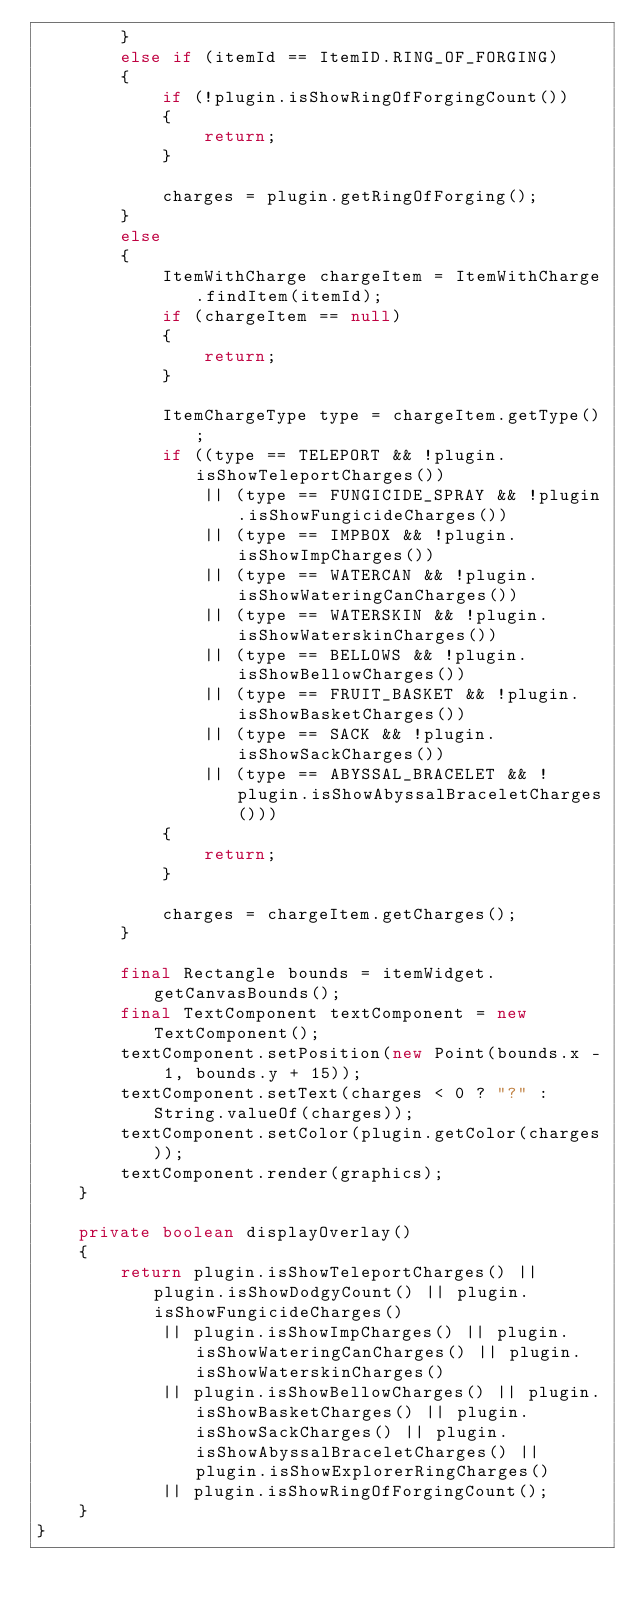Convert code to text. <code><loc_0><loc_0><loc_500><loc_500><_Java_>		}
		else if (itemId == ItemID.RING_OF_FORGING)
		{
			if (!plugin.isShowRingOfForgingCount())
			{
				return;
			}

			charges = plugin.getRingOfForging();
		}
		else
		{
			ItemWithCharge chargeItem = ItemWithCharge.findItem(itemId);
			if (chargeItem == null)
			{
				return;
			}

			ItemChargeType type = chargeItem.getType();
			if ((type == TELEPORT && !plugin.isShowTeleportCharges())
				|| (type == FUNGICIDE_SPRAY && !plugin.isShowFungicideCharges())
				|| (type == IMPBOX && !plugin.isShowImpCharges())
				|| (type == WATERCAN && !plugin.isShowWateringCanCharges())
				|| (type == WATERSKIN && !plugin.isShowWaterskinCharges())
				|| (type == BELLOWS && !plugin.isShowBellowCharges())
				|| (type == FRUIT_BASKET && !plugin.isShowBasketCharges())
				|| (type == SACK && !plugin.isShowSackCharges())
				|| (type == ABYSSAL_BRACELET && !plugin.isShowAbyssalBraceletCharges()))
			{
				return;
			}

			charges = chargeItem.getCharges();
		}

		final Rectangle bounds = itemWidget.getCanvasBounds();
		final TextComponent textComponent = new TextComponent();
		textComponent.setPosition(new Point(bounds.x - 1, bounds.y + 15));
		textComponent.setText(charges < 0 ? "?" : String.valueOf(charges));
		textComponent.setColor(plugin.getColor(charges));
		textComponent.render(graphics);
	}

	private boolean displayOverlay()
	{
		return plugin.isShowTeleportCharges() || plugin.isShowDodgyCount() || plugin.isShowFungicideCharges()
			|| plugin.isShowImpCharges() || plugin.isShowWateringCanCharges() || plugin.isShowWaterskinCharges()
			|| plugin.isShowBellowCharges() || plugin.isShowBasketCharges() || plugin.isShowSackCharges() || plugin.isShowAbyssalBraceletCharges() || plugin.isShowExplorerRingCharges()
			|| plugin.isShowRingOfForgingCount();
	}
}
</code> 